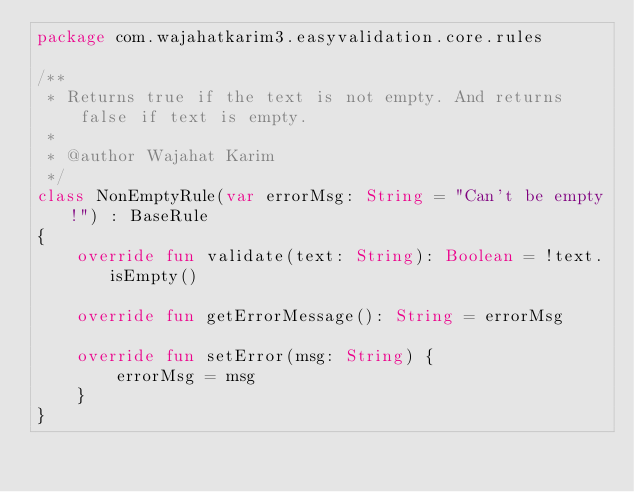<code> <loc_0><loc_0><loc_500><loc_500><_Kotlin_>package com.wajahatkarim3.easyvalidation.core.rules

/**
 * Returns true if the text is not empty. And returns false if text is empty.
 *
 * @author Wajahat Karim
 */
class NonEmptyRule(var errorMsg: String = "Can't be empty!") : BaseRule
{
    override fun validate(text: String): Boolean = !text.isEmpty()

    override fun getErrorMessage(): String = errorMsg

    override fun setError(msg: String) {
        errorMsg = msg
    }
}</code> 